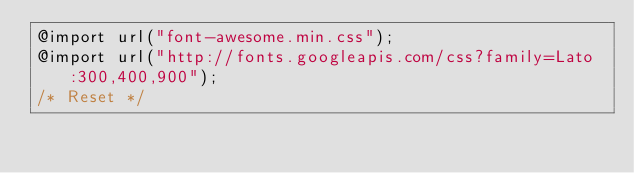Convert code to text. <code><loc_0><loc_0><loc_500><loc_500><_CSS_>@import url("font-awesome.min.css");
@import url("http://fonts.googleapis.com/css?family=Lato:300,400,900");
/* Reset */
</code> 